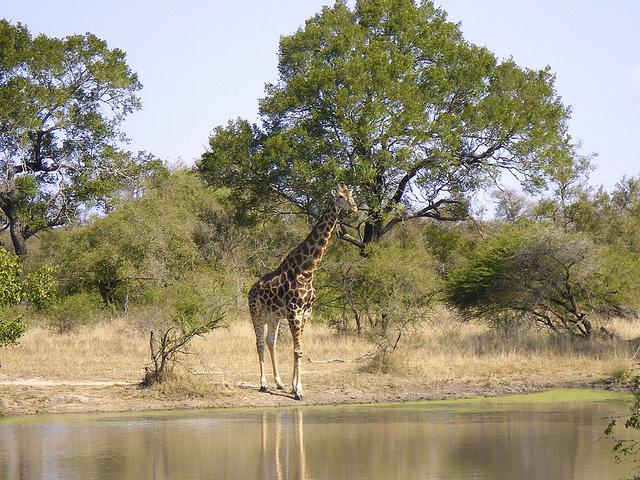What is the weather in the picture?
Concise answer only. Sunny. Are the animals dry?
Keep it brief. Yes. Is the giraffe drinking from the river?
Answer briefly. No. Is this a farm?
Give a very brief answer. No. What color is the grass?
Give a very brief answer. Brown. What animal is standing by the bank?
Give a very brief answer. Giraffe. What color is the water?
Be succinct. Brown. Is there a dog in the picture?
Write a very short answer. No. Will the giraffe enter the water?
Keep it brief. No. What type of animal are these?
Keep it brief. Giraffe. Is this a swamp?
Give a very brief answer. No. What animals are on the other side of the river?
Keep it brief. Giraffe. 